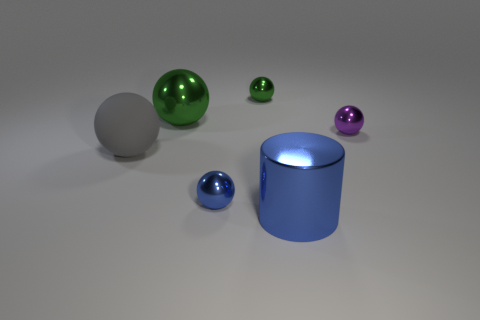Subtract all purple balls. How many balls are left? 4 Subtract all cyan balls. Subtract all green cylinders. How many balls are left? 5 Add 2 large cyan balls. How many objects exist? 8 Subtract all balls. How many objects are left? 1 Subtract 1 blue spheres. How many objects are left? 5 Subtract all tiny red cylinders. Subtract all large blue shiny things. How many objects are left? 5 Add 4 blue balls. How many blue balls are left? 5 Add 1 metallic cylinders. How many metallic cylinders exist? 2 